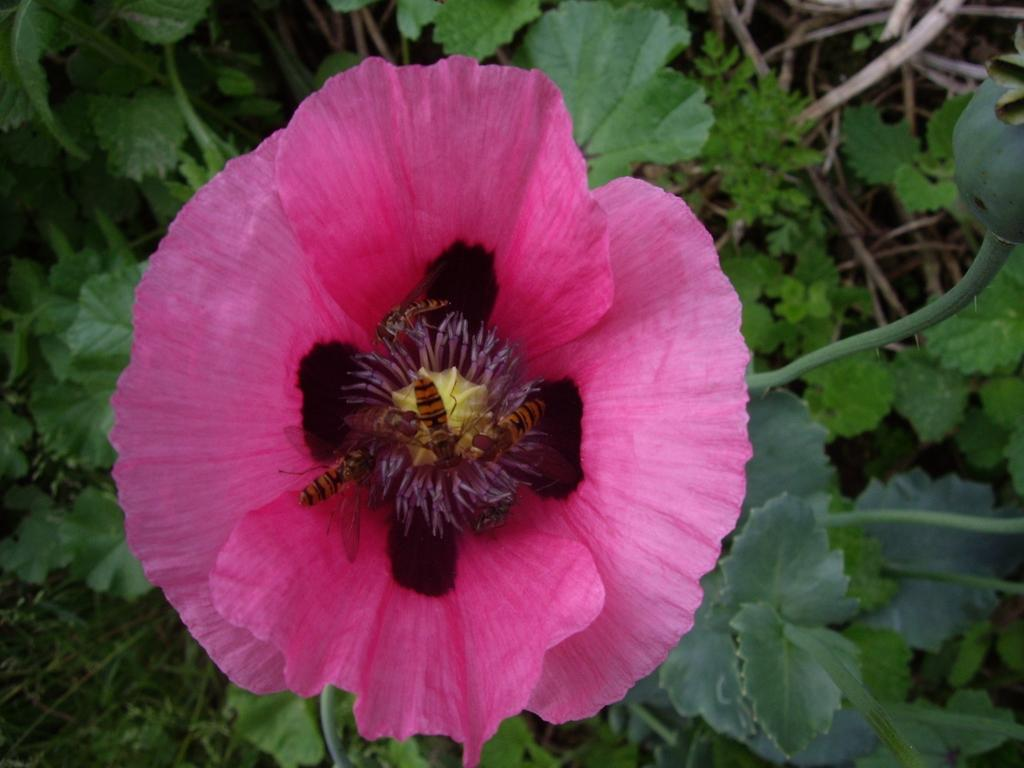What type of animals can be seen in the image? Bees can be seen in the image. Where are the bees located in relation to the plant? The bees are near the flower of a plant. What type of school can be seen in the image? There is no school present in the image; it features bees near the flower of a plant. What type of birds can be seen flying in the image? There are no birds present in the image. 